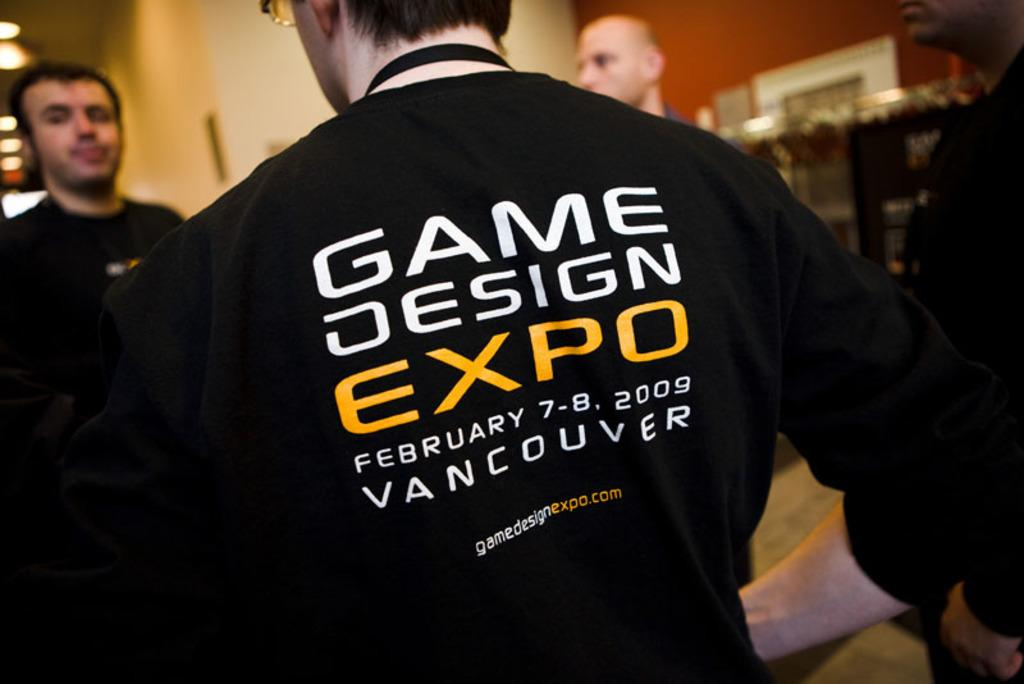Provide a one-sentence caption for the provided image. A man wearing a black Game Design Expo shirt is standing with two other men. 